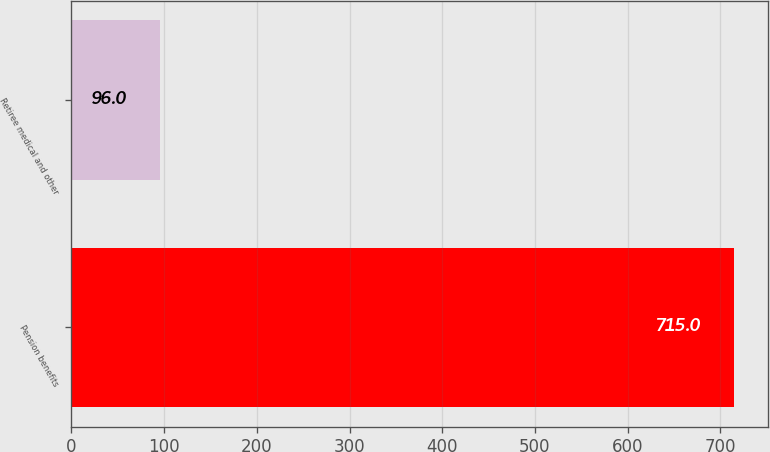<chart> <loc_0><loc_0><loc_500><loc_500><bar_chart><fcel>Pension benefits<fcel>Retiree medical and other<nl><fcel>715<fcel>96<nl></chart> 